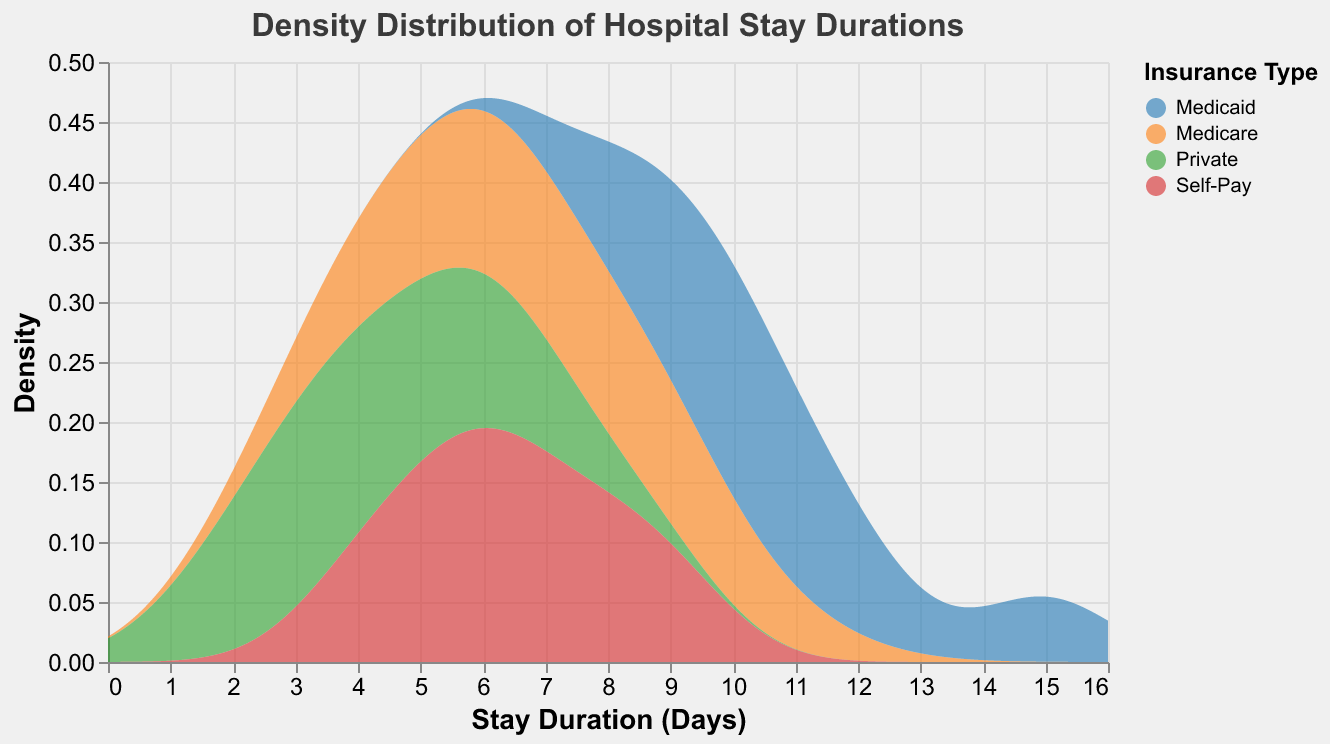What is the title of the figure? The title is usually displayed at the top of the plot. It provides a brief description of what the figure represents.
Answer: Density Distribution of Hospital Stay Durations What are the units used on the x-axis? The x-axis units are identified by the label next to the axis. In this case, it is labeled "Stay Duration (Days)".
Answer: Days What are the different categories represented by the colors? The legend on the plot shows categories represented by different colors, which in this case are the insurance types.
Answer: Medicare, Private, Medicaid, Self-Pay Which insurance type has the broadest range of hospital stay durations? To find the insurance type with the broadest range of stay durations, look for the density curve that spans the highest range on the x-axis.
Answer: Medicaid Which category has the most concentrated peak density for hospital stay durations? The concentrated peak can be identified by finding the highest point in the density curves; the insurance category with the sharpest peak represents this.
Answer: Private Around how many days does the peak density for Medicare occur? Identify the highest point of the Medicare density curve and read the corresponding x-axis value.
Answer: Approximately 7 days Compare the peak density values for Medicare and Medicaid. Which is higher? Look at the highest points of the density curves for Medicare and Medicaid and compare their y-axis values.
Answer: Medicare Do Self-Pay and Private insurance categories have overlapping densities in any stay duration range? Look for areas where the density curves of Self-Pay and Private overlap on the x-axis.
Answer: Yes What is the approximate highest stay duration for Medicaid? Identify the farthest right point at which the Medicaid density curve remains above zero.
Answer: Approximately 15 days Is there a significant difference in the distribution shapes between Medicare and Self-Pay? Compare the shapes of the density curves for Medicare and Self-Pay to determine significant differences like peak locations and spread.
Answer: Yes 